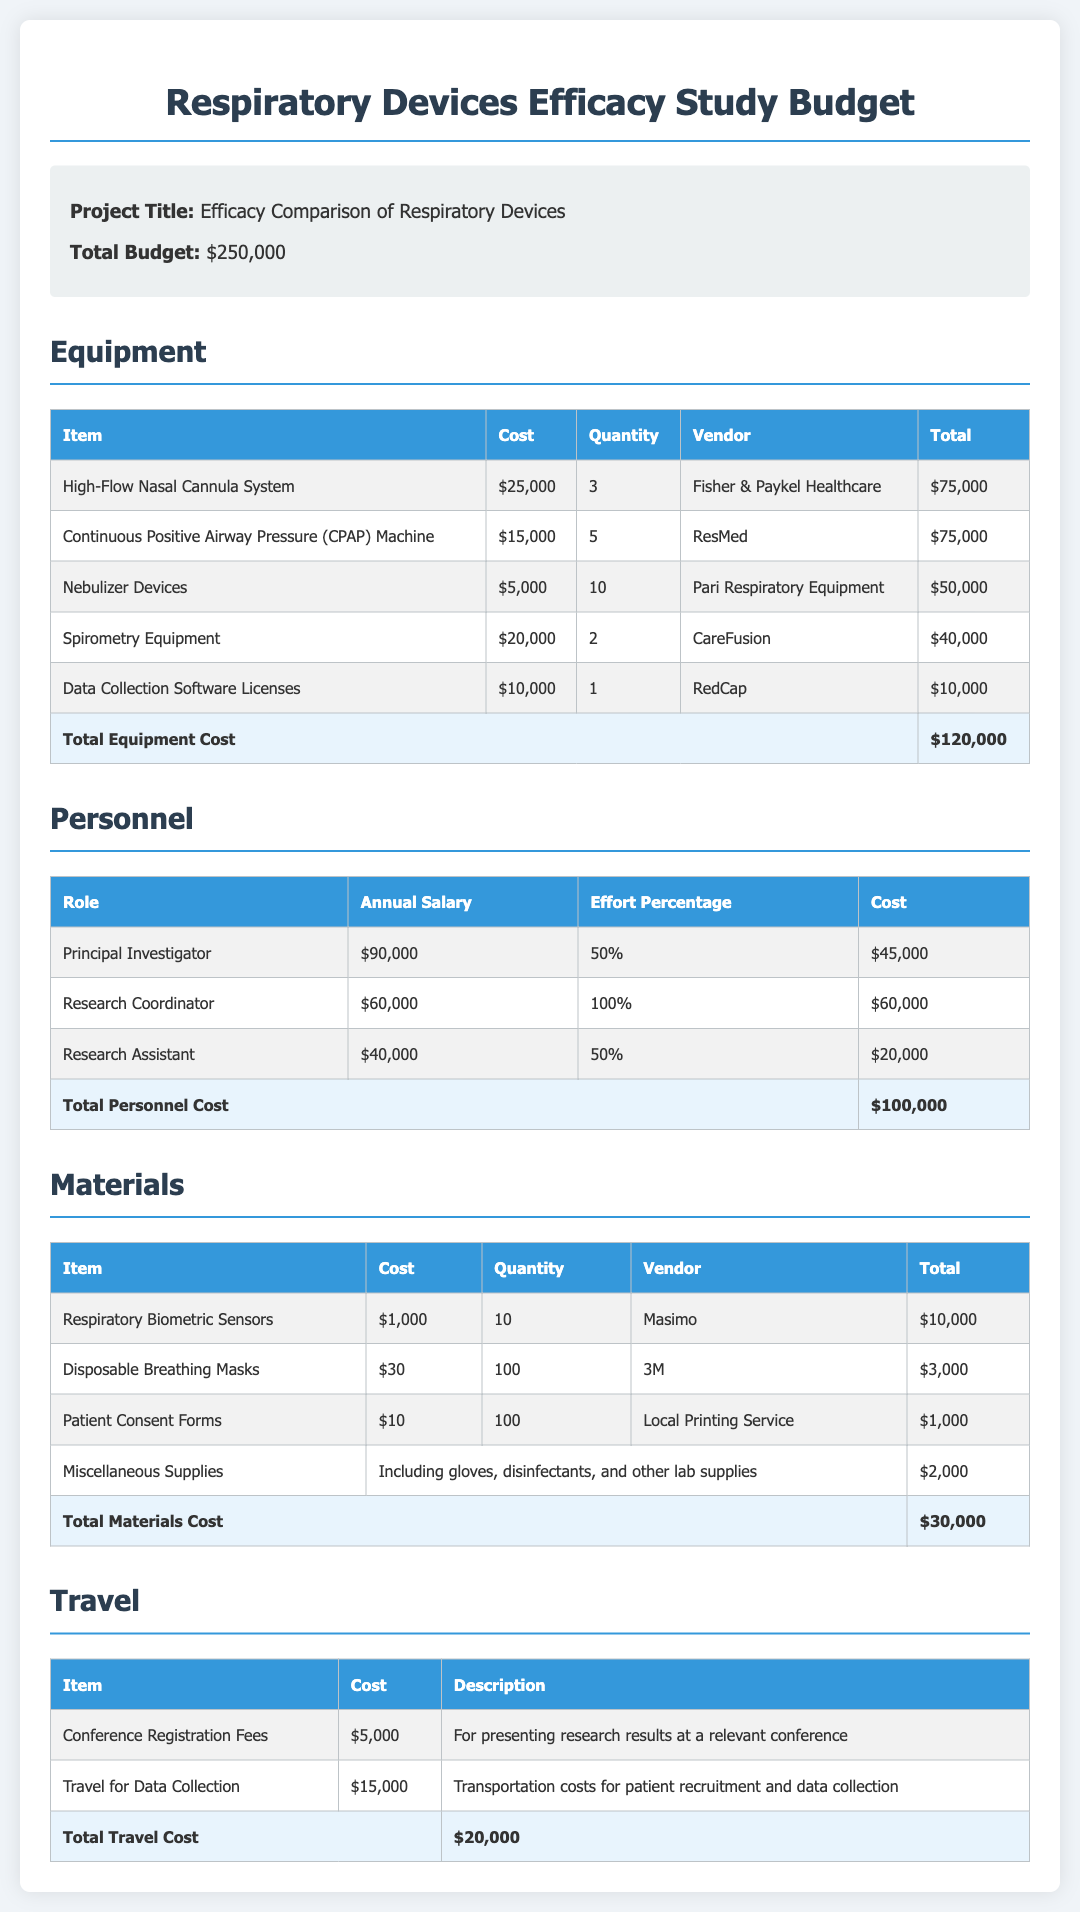What is the total budget for the study? The total budget is explicitly listed in the document as $250,000.
Answer: $250,000 How many High-Flow Nasal Cannula Systems are being purchased? The document specifies that 3 High-Flow Nasal Cannula Systems are required for the study.
Answer: 3 What is the annual salary of the Research Coordinator? The document provides the annual salary of the Research Coordinator as $60,000.
Answer: $60,000 What is the total equipment cost? The total equipment cost is summarized at the end of the equipment section as $120,000.
Answer: $120,000 Which vendor supplies the Data Collection Software Licenses? The document indicates that the Data Collection Software Licenses are provided by RedCap.
Answer: RedCap What percentage of effort is attributed to the Principal Investigator? The Principal Investigator's effort percentage is stated in the personnel section as 50%.
Answer: 50% What type of supplies are included in the "Miscellaneous Supplies" category? The document mentions that miscellaneous supplies include gloves, disinfectants, and other lab supplies.
Answer: Gloves, disinfectants, and other lab supplies What is the cost for travel related to data collection? The travel costs for data collection are listed as $15,000.
Answer: $15,000 How many respiratory biometric sensors are being purchased? According to the materials section, 10 respiratory biometric sensors are being purchased.
Answer: 10 